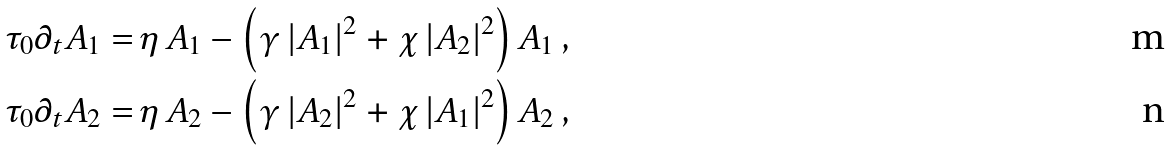Convert formula to latex. <formula><loc_0><loc_0><loc_500><loc_500>\tau _ { 0 } \partial _ { t } A _ { 1 } = & \, \eta \, A _ { 1 } - \left ( \gamma \, | A _ { 1 } | ^ { 2 } + \chi \, | A _ { 2 } | ^ { 2 } \right ) A _ { 1 } \, , \\ \tau _ { 0 } \partial _ { t } A _ { 2 } = & \, \eta \, A _ { 2 } - \left ( \gamma \, | A _ { 2 } | ^ { 2 } + \chi \, | A _ { 1 } | ^ { 2 } \right ) A _ { 2 } \, ,</formula> 